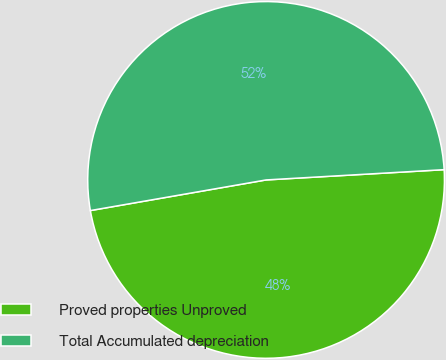<chart> <loc_0><loc_0><loc_500><loc_500><pie_chart><fcel>Proved properties Unproved<fcel>Total Accumulated depreciation<nl><fcel>48.17%<fcel>51.83%<nl></chart> 